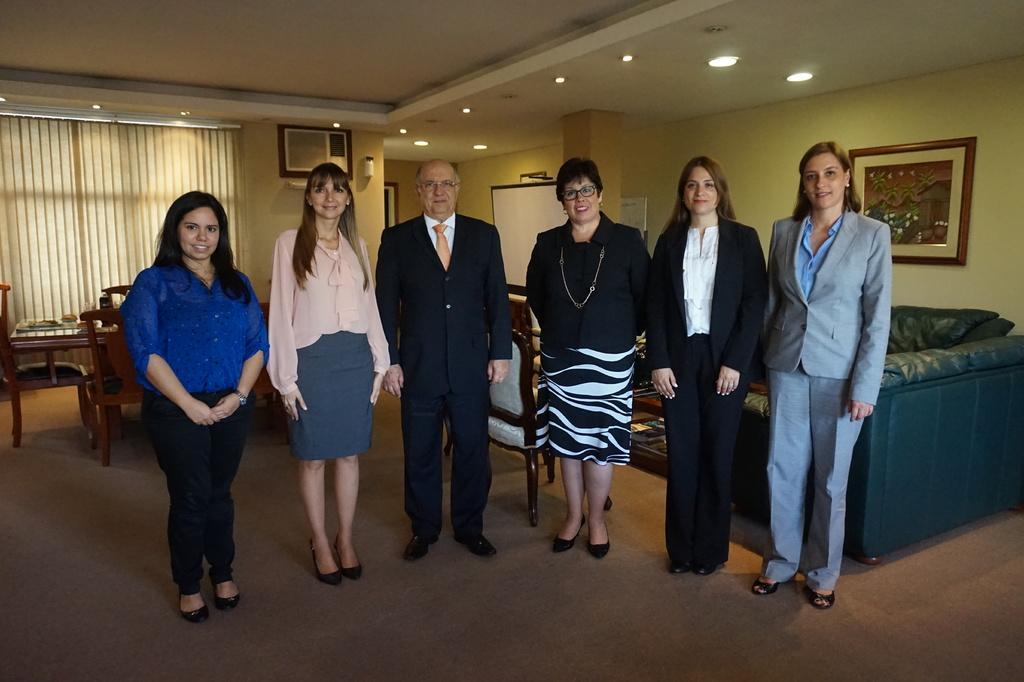Please provide a concise description of this image. In this image I can see six persons are standing on the floor. In the background I can see sofas, tables and chairs. On the top I can see a curtain blind, wall, wall painting and a rooftop. This image is taken in a hall. 